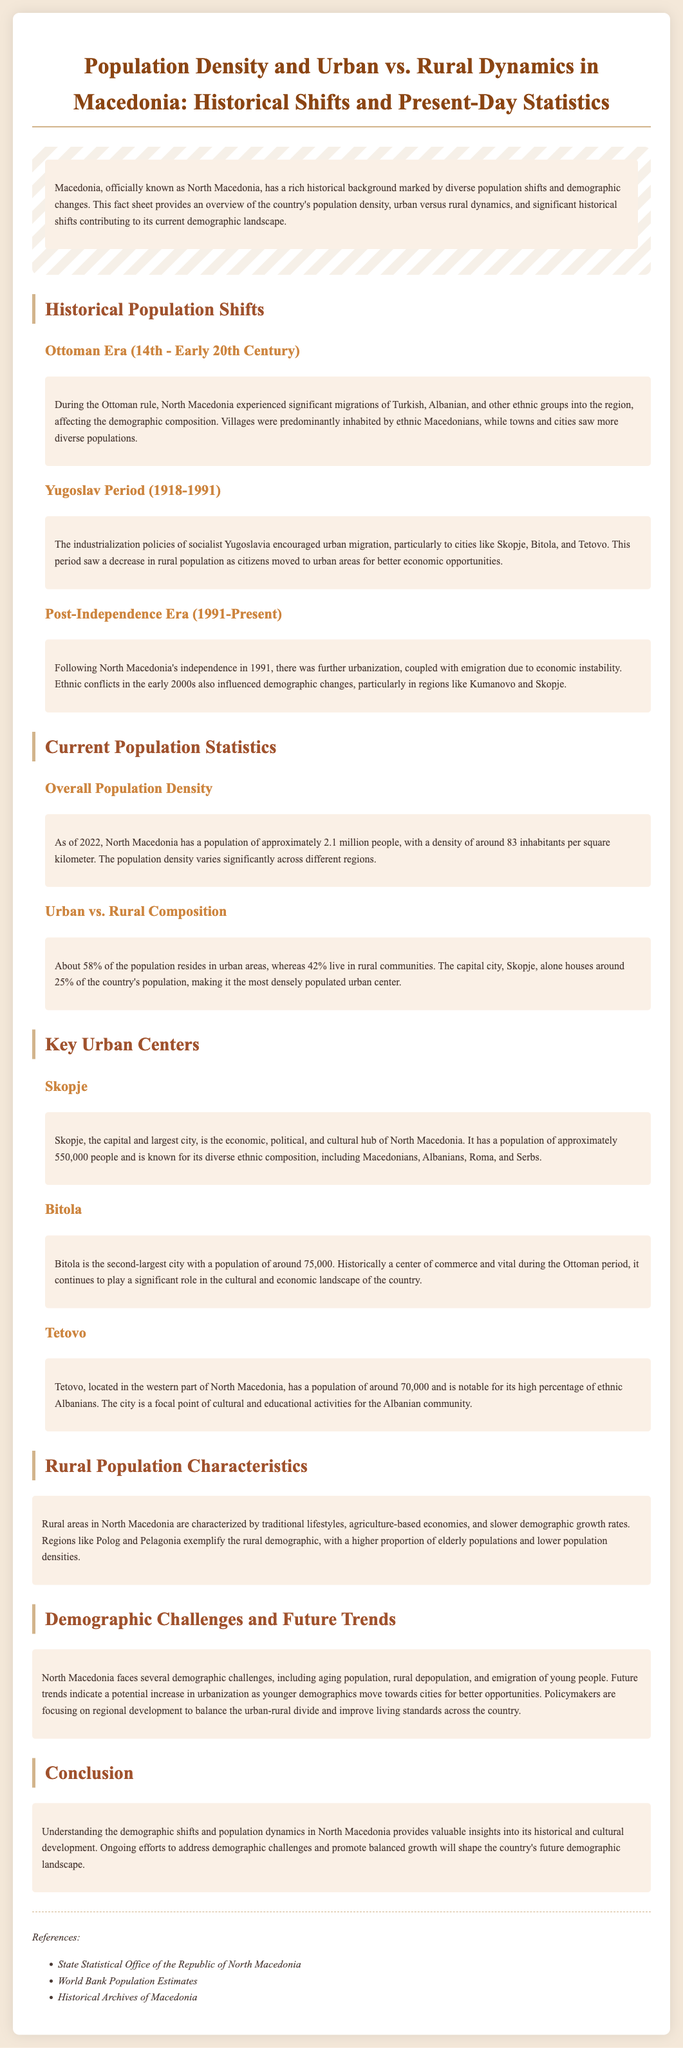What percentage of the population lives in urban areas? The document states that about 58% of the population resides in urban areas.
Answer: 58% What city houses around 25% of the country's population? The capital city Skopje is mentioned as housing around 25% of the country's population.
Answer: Skopje What was a significant factor for urban migration during the Yugoslav period? The document notes that industrialization policies encouraged urban migration during the Yugoslav period.
Answer: Industrialization As of 2022, what is the population density of North Macedonia? The fact sheet indicates that the population density is around 83 inhabitants per square kilometer.
Answer: 83 Which city is noted for its diverse ethnic composition? The document describes Skopje as known for its diverse ethnic composition.
Answer: Skopje What are the demographic characteristics of rural areas in North Macedonia? Rural areas are characterized by traditional lifestyles and agriculture-based economies, as mentioned in the document.
Answer: Traditional lifestyles What demographic challenge is highlighted in the document? The document points out aging population as one of the demographic challenges faced by North Macedonia.
Answer: Aging population During which era did significant migrations of Turkish and Albanian groups occur? The fact sheet states that these migrations occurred during the Ottoman era.
Answer: Ottoman Era 